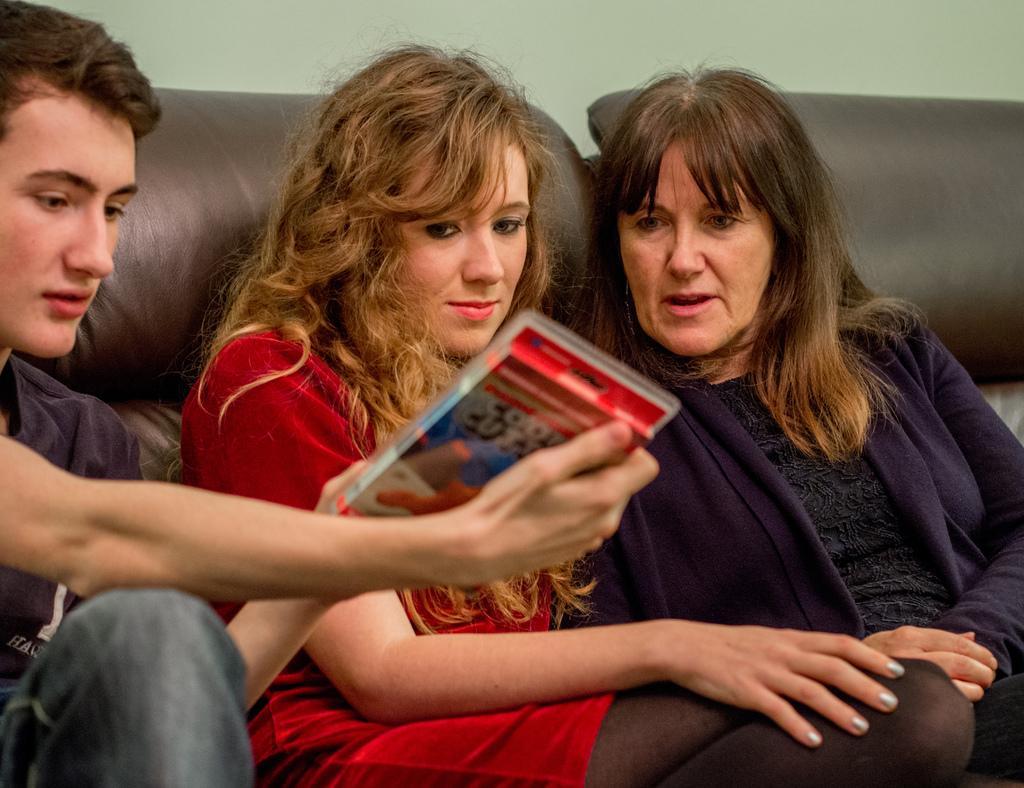How would you summarize this image in a sentence or two? In this image there are three persons who are sitting and one person is holding some packet, and in the background there is a couch and a wall. 